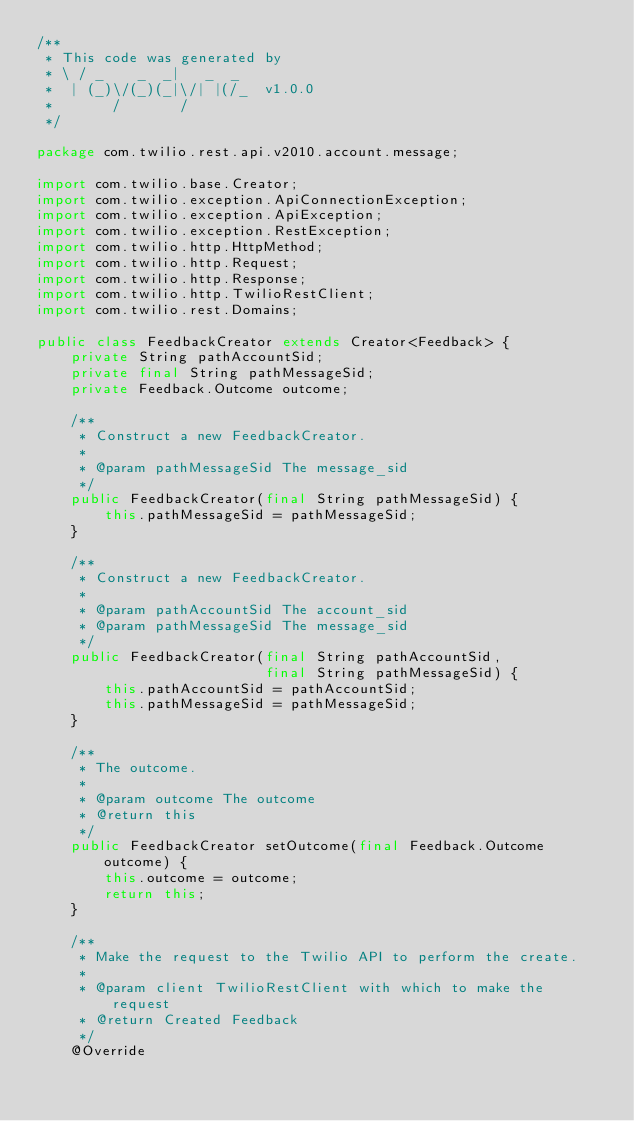Convert code to text. <code><loc_0><loc_0><loc_500><loc_500><_Java_>/**
 * This code was generated by
 * \ / _    _  _|   _  _
 *  | (_)\/(_)(_|\/| |(/_  v1.0.0
 *       /       /
 */

package com.twilio.rest.api.v2010.account.message;

import com.twilio.base.Creator;
import com.twilio.exception.ApiConnectionException;
import com.twilio.exception.ApiException;
import com.twilio.exception.RestException;
import com.twilio.http.HttpMethod;
import com.twilio.http.Request;
import com.twilio.http.Response;
import com.twilio.http.TwilioRestClient;
import com.twilio.rest.Domains;

public class FeedbackCreator extends Creator<Feedback> {
    private String pathAccountSid;
    private final String pathMessageSid;
    private Feedback.Outcome outcome;

    /**
     * Construct a new FeedbackCreator.
     * 
     * @param pathMessageSid The message_sid
     */
    public FeedbackCreator(final String pathMessageSid) {
        this.pathMessageSid = pathMessageSid;
    }

    /**
     * Construct a new FeedbackCreator.
     * 
     * @param pathAccountSid The account_sid
     * @param pathMessageSid The message_sid
     */
    public FeedbackCreator(final String pathAccountSid, 
                           final String pathMessageSid) {
        this.pathAccountSid = pathAccountSid;
        this.pathMessageSid = pathMessageSid;
    }

    /**
     * The outcome.
     * 
     * @param outcome The outcome
     * @return this
     */
    public FeedbackCreator setOutcome(final Feedback.Outcome outcome) {
        this.outcome = outcome;
        return this;
    }

    /**
     * Make the request to the Twilio API to perform the create.
     * 
     * @param client TwilioRestClient with which to make the request
     * @return Created Feedback
     */
    @Override</code> 